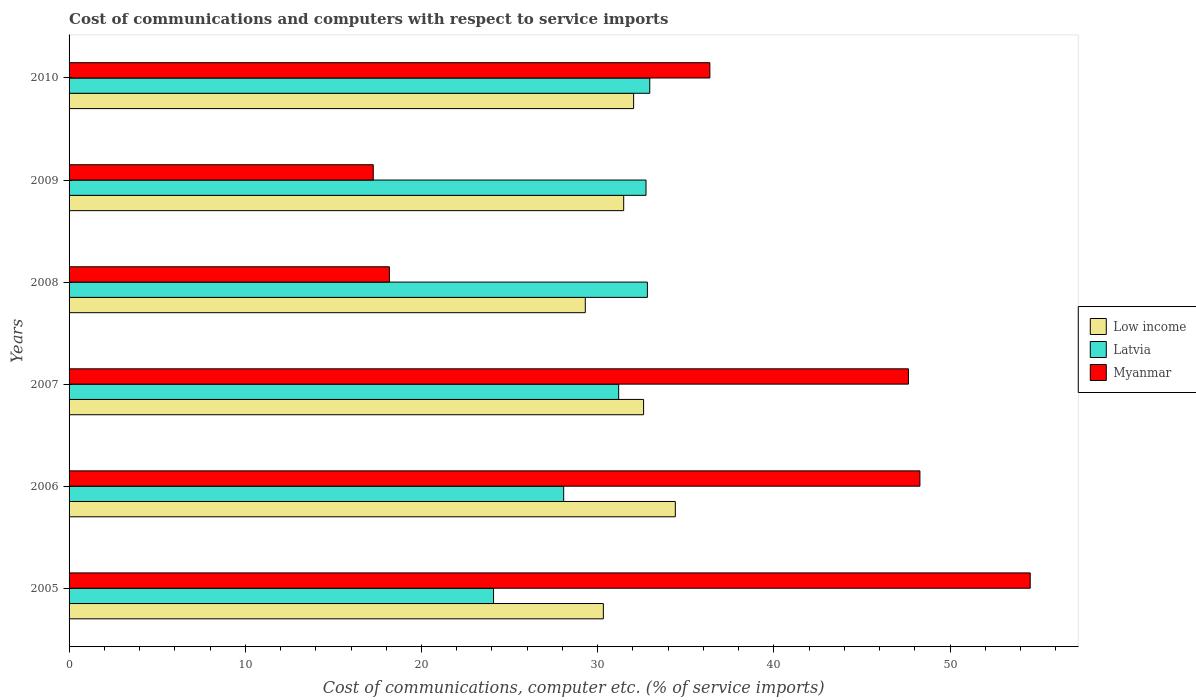How many different coloured bars are there?
Make the answer very short. 3. How many groups of bars are there?
Your response must be concise. 6. In how many cases, is the number of bars for a given year not equal to the number of legend labels?
Keep it short and to the point. 0. What is the cost of communications and computers in Latvia in 2006?
Make the answer very short. 28.07. Across all years, what is the maximum cost of communications and computers in Latvia?
Keep it short and to the point. 32.95. Across all years, what is the minimum cost of communications and computers in Myanmar?
Offer a terse response. 17.26. What is the total cost of communications and computers in Myanmar in the graph?
Provide a succinct answer. 222.28. What is the difference between the cost of communications and computers in Latvia in 2007 and that in 2008?
Make the answer very short. -1.63. What is the difference between the cost of communications and computers in Low income in 2010 and the cost of communications and computers in Latvia in 2008?
Provide a short and direct response. -0.78. What is the average cost of communications and computers in Latvia per year?
Keep it short and to the point. 30.31. In the year 2005, what is the difference between the cost of communications and computers in Myanmar and cost of communications and computers in Latvia?
Offer a very short reply. 30.46. In how many years, is the cost of communications and computers in Low income greater than 12 %?
Your response must be concise. 6. What is the ratio of the cost of communications and computers in Myanmar in 2005 to that in 2008?
Make the answer very short. 3. Is the difference between the cost of communications and computers in Myanmar in 2007 and 2009 greater than the difference between the cost of communications and computers in Latvia in 2007 and 2009?
Give a very brief answer. Yes. What is the difference between the highest and the second highest cost of communications and computers in Low income?
Your answer should be very brief. 1.8. What is the difference between the highest and the lowest cost of communications and computers in Latvia?
Your response must be concise. 8.87. In how many years, is the cost of communications and computers in Latvia greater than the average cost of communications and computers in Latvia taken over all years?
Offer a very short reply. 4. Is the sum of the cost of communications and computers in Low income in 2006 and 2008 greater than the maximum cost of communications and computers in Myanmar across all years?
Give a very brief answer. Yes. What does the 2nd bar from the top in 2009 represents?
Your answer should be very brief. Latvia. What does the 1st bar from the bottom in 2010 represents?
Offer a terse response. Low income. How many years are there in the graph?
Make the answer very short. 6. What is the difference between two consecutive major ticks on the X-axis?
Provide a short and direct response. 10. Are the values on the major ticks of X-axis written in scientific E-notation?
Give a very brief answer. No. How many legend labels are there?
Keep it short and to the point. 3. How are the legend labels stacked?
Your response must be concise. Vertical. What is the title of the graph?
Provide a succinct answer. Cost of communications and computers with respect to service imports. Does "OECD members" appear as one of the legend labels in the graph?
Offer a terse response. No. What is the label or title of the X-axis?
Provide a short and direct response. Cost of communications, computer etc. (% of service imports). What is the label or title of the Y-axis?
Provide a short and direct response. Years. What is the Cost of communications, computer etc. (% of service imports) in Low income in 2005?
Your answer should be compact. 30.32. What is the Cost of communications, computer etc. (% of service imports) in Latvia in 2005?
Ensure brevity in your answer.  24.09. What is the Cost of communications, computer etc. (% of service imports) in Myanmar in 2005?
Provide a succinct answer. 54.55. What is the Cost of communications, computer etc. (% of service imports) of Low income in 2006?
Your response must be concise. 34.41. What is the Cost of communications, computer etc. (% of service imports) of Latvia in 2006?
Ensure brevity in your answer.  28.07. What is the Cost of communications, computer etc. (% of service imports) in Myanmar in 2006?
Your response must be concise. 48.29. What is the Cost of communications, computer etc. (% of service imports) of Low income in 2007?
Offer a very short reply. 32.6. What is the Cost of communications, computer etc. (% of service imports) of Latvia in 2007?
Ensure brevity in your answer.  31.19. What is the Cost of communications, computer etc. (% of service imports) of Myanmar in 2007?
Provide a succinct answer. 47.64. What is the Cost of communications, computer etc. (% of service imports) in Low income in 2008?
Your response must be concise. 29.3. What is the Cost of communications, computer etc. (% of service imports) in Latvia in 2008?
Ensure brevity in your answer.  32.82. What is the Cost of communications, computer etc. (% of service imports) in Myanmar in 2008?
Provide a short and direct response. 18.18. What is the Cost of communications, computer etc. (% of service imports) of Low income in 2009?
Make the answer very short. 31.48. What is the Cost of communications, computer etc. (% of service imports) of Latvia in 2009?
Give a very brief answer. 32.74. What is the Cost of communications, computer etc. (% of service imports) of Myanmar in 2009?
Provide a succinct answer. 17.26. What is the Cost of communications, computer etc. (% of service imports) in Low income in 2010?
Offer a terse response. 32.04. What is the Cost of communications, computer etc. (% of service imports) of Latvia in 2010?
Your answer should be compact. 32.95. What is the Cost of communications, computer etc. (% of service imports) of Myanmar in 2010?
Ensure brevity in your answer.  36.37. Across all years, what is the maximum Cost of communications, computer etc. (% of service imports) of Low income?
Provide a short and direct response. 34.41. Across all years, what is the maximum Cost of communications, computer etc. (% of service imports) in Latvia?
Provide a short and direct response. 32.95. Across all years, what is the maximum Cost of communications, computer etc. (% of service imports) of Myanmar?
Ensure brevity in your answer.  54.55. Across all years, what is the minimum Cost of communications, computer etc. (% of service imports) of Low income?
Give a very brief answer. 29.3. Across all years, what is the minimum Cost of communications, computer etc. (% of service imports) of Latvia?
Provide a short and direct response. 24.09. Across all years, what is the minimum Cost of communications, computer etc. (% of service imports) in Myanmar?
Make the answer very short. 17.26. What is the total Cost of communications, computer etc. (% of service imports) of Low income in the graph?
Provide a short and direct response. 190.14. What is the total Cost of communications, computer etc. (% of service imports) of Latvia in the graph?
Ensure brevity in your answer.  181.87. What is the total Cost of communications, computer etc. (% of service imports) in Myanmar in the graph?
Make the answer very short. 222.28. What is the difference between the Cost of communications, computer etc. (% of service imports) of Low income in 2005 and that in 2006?
Provide a succinct answer. -4.08. What is the difference between the Cost of communications, computer etc. (% of service imports) of Latvia in 2005 and that in 2006?
Offer a very short reply. -3.98. What is the difference between the Cost of communications, computer etc. (% of service imports) of Myanmar in 2005 and that in 2006?
Ensure brevity in your answer.  6.26. What is the difference between the Cost of communications, computer etc. (% of service imports) in Low income in 2005 and that in 2007?
Your answer should be compact. -2.28. What is the difference between the Cost of communications, computer etc. (% of service imports) of Latvia in 2005 and that in 2007?
Your answer should be compact. -7.1. What is the difference between the Cost of communications, computer etc. (% of service imports) in Myanmar in 2005 and that in 2007?
Your answer should be very brief. 6.91. What is the difference between the Cost of communications, computer etc. (% of service imports) of Low income in 2005 and that in 2008?
Give a very brief answer. 1.03. What is the difference between the Cost of communications, computer etc. (% of service imports) of Latvia in 2005 and that in 2008?
Your answer should be very brief. -8.73. What is the difference between the Cost of communications, computer etc. (% of service imports) of Myanmar in 2005 and that in 2008?
Your response must be concise. 36.37. What is the difference between the Cost of communications, computer etc. (% of service imports) of Low income in 2005 and that in 2009?
Offer a terse response. -1.15. What is the difference between the Cost of communications, computer etc. (% of service imports) of Latvia in 2005 and that in 2009?
Your answer should be compact. -8.65. What is the difference between the Cost of communications, computer etc. (% of service imports) in Myanmar in 2005 and that in 2009?
Ensure brevity in your answer.  37.28. What is the difference between the Cost of communications, computer etc. (% of service imports) of Low income in 2005 and that in 2010?
Your answer should be compact. -1.72. What is the difference between the Cost of communications, computer etc. (% of service imports) of Latvia in 2005 and that in 2010?
Your answer should be very brief. -8.87. What is the difference between the Cost of communications, computer etc. (% of service imports) of Myanmar in 2005 and that in 2010?
Your answer should be very brief. 18.18. What is the difference between the Cost of communications, computer etc. (% of service imports) in Low income in 2006 and that in 2007?
Ensure brevity in your answer.  1.8. What is the difference between the Cost of communications, computer etc. (% of service imports) in Latvia in 2006 and that in 2007?
Keep it short and to the point. -3.12. What is the difference between the Cost of communications, computer etc. (% of service imports) of Myanmar in 2006 and that in 2007?
Make the answer very short. 0.65. What is the difference between the Cost of communications, computer etc. (% of service imports) in Low income in 2006 and that in 2008?
Your answer should be very brief. 5.11. What is the difference between the Cost of communications, computer etc. (% of service imports) of Latvia in 2006 and that in 2008?
Keep it short and to the point. -4.75. What is the difference between the Cost of communications, computer etc. (% of service imports) in Myanmar in 2006 and that in 2008?
Offer a very short reply. 30.11. What is the difference between the Cost of communications, computer etc. (% of service imports) in Low income in 2006 and that in 2009?
Offer a terse response. 2.93. What is the difference between the Cost of communications, computer etc. (% of service imports) in Latvia in 2006 and that in 2009?
Give a very brief answer. -4.67. What is the difference between the Cost of communications, computer etc. (% of service imports) of Myanmar in 2006 and that in 2009?
Offer a terse response. 31.02. What is the difference between the Cost of communications, computer etc. (% of service imports) in Low income in 2006 and that in 2010?
Ensure brevity in your answer.  2.37. What is the difference between the Cost of communications, computer etc. (% of service imports) of Latvia in 2006 and that in 2010?
Your answer should be compact. -4.88. What is the difference between the Cost of communications, computer etc. (% of service imports) in Myanmar in 2006 and that in 2010?
Your answer should be very brief. 11.92. What is the difference between the Cost of communications, computer etc. (% of service imports) of Low income in 2007 and that in 2008?
Ensure brevity in your answer.  3.31. What is the difference between the Cost of communications, computer etc. (% of service imports) of Latvia in 2007 and that in 2008?
Your response must be concise. -1.63. What is the difference between the Cost of communications, computer etc. (% of service imports) in Myanmar in 2007 and that in 2008?
Offer a terse response. 29.46. What is the difference between the Cost of communications, computer etc. (% of service imports) in Low income in 2007 and that in 2009?
Make the answer very short. 1.13. What is the difference between the Cost of communications, computer etc. (% of service imports) in Latvia in 2007 and that in 2009?
Offer a very short reply. -1.55. What is the difference between the Cost of communications, computer etc. (% of service imports) of Myanmar in 2007 and that in 2009?
Your answer should be very brief. 30.37. What is the difference between the Cost of communications, computer etc. (% of service imports) in Low income in 2007 and that in 2010?
Your response must be concise. 0.57. What is the difference between the Cost of communications, computer etc. (% of service imports) in Latvia in 2007 and that in 2010?
Offer a terse response. -1.76. What is the difference between the Cost of communications, computer etc. (% of service imports) of Myanmar in 2007 and that in 2010?
Make the answer very short. 11.27. What is the difference between the Cost of communications, computer etc. (% of service imports) of Low income in 2008 and that in 2009?
Provide a succinct answer. -2.18. What is the difference between the Cost of communications, computer etc. (% of service imports) in Latvia in 2008 and that in 2009?
Offer a terse response. 0.08. What is the difference between the Cost of communications, computer etc. (% of service imports) in Myanmar in 2008 and that in 2009?
Give a very brief answer. 0.92. What is the difference between the Cost of communications, computer etc. (% of service imports) of Low income in 2008 and that in 2010?
Provide a succinct answer. -2.74. What is the difference between the Cost of communications, computer etc. (% of service imports) of Latvia in 2008 and that in 2010?
Ensure brevity in your answer.  -0.13. What is the difference between the Cost of communications, computer etc. (% of service imports) of Myanmar in 2008 and that in 2010?
Your response must be concise. -18.19. What is the difference between the Cost of communications, computer etc. (% of service imports) of Low income in 2009 and that in 2010?
Your answer should be very brief. -0.56. What is the difference between the Cost of communications, computer etc. (% of service imports) of Latvia in 2009 and that in 2010?
Offer a very short reply. -0.21. What is the difference between the Cost of communications, computer etc. (% of service imports) in Myanmar in 2009 and that in 2010?
Provide a succinct answer. -19.1. What is the difference between the Cost of communications, computer etc. (% of service imports) in Low income in 2005 and the Cost of communications, computer etc. (% of service imports) in Latvia in 2006?
Your answer should be compact. 2.25. What is the difference between the Cost of communications, computer etc. (% of service imports) in Low income in 2005 and the Cost of communications, computer etc. (% of service imports) in Myanmar in 2006?
Offer a very short reply. -17.97. What is the difference between the Cost of communications, computer etc. (% of service imports) of Latvia in 2005 and the Cost of communications, computer etc. (% of service imports) of Myanmar in 2006?
Ensure brevity in your answer.  -24.2. What is the difference between the Cost of communications, computer etc. (% of service imports) of Low income in 2005 and the Cost of communications, computer etc. (% of service imports) of Latvia in 2007?
Give a very brief answer. -0.87. What is the difference between the Cost of communications, computer etc. (% of service imports) of Low income in 2005 and the Cost of communications, computer etc. (% of service imports) of Myanmar in 2007?
Provide a succinct answer. -17.31. What is the difference between the Cost of communications, computer etc. (% of service imports) of Latvia in 2005 and the Cost of communications, computer etc. (% of service imports) of Myanmar in 2007?
Make the answer very short. -23.55. What is the difference between the Cost of communications, computer etc. (% of service imports) of Low income in 2005 and the Cost of communications, computer etc. (% of service imports) of Latvia in 2008?
Provide a succinct answer. -2.5. What is the difference between the Cost of communications, computer etc. (% of service imports) in Low income in 2005 and the Cost of communications, computer etc. (% of service imports) in Myanmar in 2008?
Provide a short and direct response. 12.14. What is the difference between the Cost of communications, computer etc. (% of service imports) in Latvia in 2005 and the Cost of communications, computer etc. (% of service imports) in Myanmar in 2008?
Offer a very short reply. 5.91. What is the difference between the Cost of communications, computer etc. (% of service imports) in Low income in 2005 and the Cost of communications, computer etc. (% of service imports) in Latvia in 2009?
Ensure brevity in your answer.  -2.42. What is the difference between the Cost of communications, computer etc. (% of service imports) of Low income in 2005 and the Cost of communications, computer etc. (% of service imports) of Myanmar in 2009?
Offer a very short reply. 13.06. What is the difference between the Cost of communications, computer etc. (% of service imports) in Latvia in 2005 and the Cost of communications, computer etc. (% of service imports) in Myanmar in 2009?
Provide a succinct answer. 6.83. What is the difference between the Cost of communications, computer etc. (% of service imports) in Low income in 2005 and the Cost of communications, computer etc. (% of service imports) in Latvia in 2010?
Your response must be concise. -2.63. What is the difference between the Cost of communications, computer etc. (% of service imports) in Low income in 2005 and the Cost of communications, computer etc. (% of service imports) in Myanmar in 2010?
Provide a short and direct response. -6.04. What is the difference between the Cost of communications, computer etc. (% of service imports) in Latvia in 2005 and the Cost of communications, computer etc. (% of service imports) in Myanmar in 2010?
Offer a terse response. -12.28. What is the difference between the Cost of communications, computer etc. (% of service imports) in Low income in 2006 and the Cost of communications, computer etc. (% of service imports) in Latvia in 2007?
Make the answer very short. 3.21. What is the difference between the Cost of communications, computer etc. (% of service imports) in Low income in 2006 and the Cost of communications, computer etc. (% of service imports) in Myanmar in 2007?
Provide a short and direct response. -13.23. What is the difference between the Cost of communications, computer etc. (% of service imports) in Latvia in 2006 and the Cost of communications, computer etc. (% of service imports) in Myanmar in 2007?
Your response must be concise. -19.57. What is the difference between the Cost of communications, computer etc. (% of service imports) of Low income in 2006 and the Cost of communications, computer etc. (% of service imports) of Latvia in 2008?
Your response must be concise. 1.58. What is the difference between the Cost of communications, computer etc. (% of service imports) in Low income in 2006 and the Cost of communications, computer etc. (% of service imports) in Myanmar in 2008?
Offer a terse response. 16.23. What is the difference between the Cost of communications, computer etc. (% of service imports) of Latvia in 2006 and the Cost of communications, computer etc. (% of service imports) of Myanmar in 2008?
Provide a succinct answer. 9.89. What is the difference between the Cost of communications, computer etc. (% of service imports) in Low income in 2006 and the Cost of communications, computer etc. (% of service imports) in Latvia in 2009?
Make the answer very short. 1.66. What is the difference between the Cost of communications, computer etc. (% of service imports) in Low income in 2006 and the Cost of communications, computer etc. (% of service imports) in Myanmar in 2009?
Provide a short and direct response. 17.14. What is the difference between the Cost of communications, computer etc. (% of service imports) in Latvia in 2006 and the Cost of communications, computer etc. (% of service imports) in Myanmar in 2009?
Ensure brevity in your answer.  10.81. What is the difference between the Cost of communications, computer etc. (% of service imports) of Low income in 2006 and the Cost of communications, computer etc. (% of service imports) of Latvia in 2010?
Your answer should be very brief. 1.45. What is the difference between the Cost of communications, computer etc. (% of service imports) in Low income in 2006 and the Cost of communications, computer etc. (% of service imports) in Myanmar in 2010?
Give a very brief answer. -1.96. What is the difference between the Cost of communications, computer etc. (% of service imports) in Latvia in 2006 and the Cost of communications, computer etc. (% of service imports) in Myanmar in 2010?
Your answer should be compact. -8.3. What is the difference between the Cost of communications, computer etc. (% of service imports) in Low income in 2007 and the Cost of communications, computer etc. (% of service imports) in Latvia in 2008?
Keep it short and to the point. -0.22. What is the difference between the Cost of communications, computer etc. (% of service imports) in Low income in 2007 and the Cost of communications, computer etc. (% of service imports) in Myanmar in 2008?
Your answer should be very brief. 14.43. What is the difference between the Cost of communications, computer etc. (% of service imports) in Latvia in 2007 and the Cost of communications, computer etc. (% of service imports) in Myanmar in 2008?
Your answer should be compact. 13.01. What is the difference between the Cost of communications, computer etc. (% of service imports) of Low income in 2007 and the Cost of communications, computer etc. (% of service imports) of Latvia in 2009?
Offer a terse response. -0.14. What is the difference between the Cost of communications, computer etc. (% of service imports) in Low income in 2007 and the Cost of communications, computer etc. (% of service imports) in Myanmar in 2009?
Provide a succinct answer. 15.34. What is the difference between the Cost of communications, computer etc. (% of service imports) in Latvia in 2007 and the Cost of communications, computer etc. (% of service imports) in Myanmar in 2009?
Your answer should be compact. 13.93. What is the difference between the Cost of communications, computer etc. (% of service imports) of Low income in 2007 and the Cost of communications, computer etc. (% of service imports) of Latvia in 2010?
Provide a succinct answer. -0.35. What is the difference between the Cost of communications, computer etc. (% of service imports) of Low income in 2007 and the Cost of communications, computer etc. (% of service imports) of Myanmar in 2010?
Make the answer very short. -3.76. What is the difference between the Cost of communications, computer etc. (% of service imports) of Latvia in 2007 and the Cost of communications, computer etc. (% of service imports) of Myanmar in 2010?
Your response must be concise. -5.17. What is the difference between the Cost of communications, computer etc. (% of service imports) of Low income in 2008 and the Cost of communications, computer etc. (% of service imports) of Latvia in 2009?
Offer a terse response. -3.45. What is the difference between the Cost of communications, computer etc. (% of service imports) of Low income in 2008 and the Cost of communications, computer etc. (% of service imports) of Myanmar in 2009?
Provide a short and direct response. 12.03. What is the difference between the Cost of communications, computer etc. (% of service imports) of Latvia in 2008 and the Cost of communications, computer etc. (% of service imports) of Myanmar in 2009?
Ensure brevity in your answer.  15.56. What is the difference between the Cost of communications, computer etc. (% of service imports) of Low income in 2008 and the Cost of communications, computer etc. (% of service imports) of Latvia in 2010?
Ensure brevity in your answer.  -3.66. What is the difference between the Cost of communications, computer etc. (% of service imports) of Low income in 2008 and the Cost of communications, computer etc. (% of service imports) of Myanmar in 2010?
Your response must be concise. -7.07. What is the difference between the Cost of communications, computer etc. (% of service imports) of Latvia in 2008 and the Cost of communications, computer etc. (% of service imports) of Myanmar in 2010?
Keep it short and to the point. -3.54. What is the difference between the Cost of communications, computer etc. (% of service imports) of Low income in 2009 and the Cost of communications, computer etc. (% of service imports) of Latvia in 2010?
Make the answer very short. -1.48. What is the difference between the Cost of communications, computer etc. (% of service imports) of Low income in 2009 and the Cost of communications, computer etc. (% of service imports) of Myanmar in 2010?
Your response must be concise. -4.89. What is the difference between the Cost of communications, computer etc. (% of service imports) in Latvia in 2009 and the Cost of communications, computer etc. (% of service imports) in Myanmar in 2010?
Offer a terse response. -3.62. What is the average Cost of communications, computer etc. (% of service imports) of Low income per year?
Provide a short and direct response. 31.69. What is the average Cost of communications, computer etc. (% of service imports) of Latvia per year?
Your answer should be very brief. 30.31. What is the average Cost of communications, computer etc. (% of service imports) in Myanmar per year?
Provide a short and direct response. 37.05. In the year 2005, what is the difference between the Cost of communications, computer etc. (% of service imports) in Low income and Cost of communications, computer etc. (% of service imports) in Latvia?
Offer a very short reply. 6.23. In the year 2005, what is the difference between the Cost of communications, computer etc. (% of service imports) of Low income and Cost of communications, computer etc. (% of service imports) of Myanmar?
Give a very brief answer. -24.22. In the year 2005, what is the difference between the Cost of communications, computer etc. (% of service imports) of Latvia and Cost of communications, computer etc. (% of service imports) of Myanmar?
Keep it short and to the point. -30.46. In the year 2006, what is the difference between the Cost of communications, computer etc. (% of service imports) in Low income and Cost of communications, computer etc. (% of service imports) in Latvia?
Your answer should be very brief. 6.34. In the year 2006, what is the difference between the Cost of communications, computer etc. (% of service imports) of Low income and Cost of communications, computer etc. (% of service imports) of Myanmar?
Your answer should be compact. -13.88. In the year 2006, what is the difference between the Cost of communications, computer etc. (% of service imports) of Latvia and Cost of communications, computer etc. (% of service imports) of Myanmar?
Ensure brevity in your answer.  -20.22. In the year 2007, what is the difference between the Cost of communications, computer etc. (% of service imports) in Low income and Cost of communications, computer etc. (% of service imports) in Latvia?
Provide a short and direct response. 1.41. In the year 2007, what is the difference between the Cost of communications, computer etc. (% of service imports) in Low income and Cost of communications, computer etc. (% of service imports) in Myanmar?
Your answer should be very brief. -15.03. In the year 2007, what is the difference between the Cost of communications, computer etc. (% of service imports) of Latvia and Cost of communications, computer etc. (% of service imports) of Myanmar?
Provide a short and direct response. -16.44. In the year 2008, what is the difference between the Cost of communications, computer etc. (% of service imports) of Low income and Cost of communications, computer etc. (% of service imports) of Latvia?
Provide a succinct answer. -3.52. In the year 2008, what is the difference between the Cost of communications, computer etc. (% of service imports) in Low income and Cost of communications, computer etc. (% of service imports) in Myanmar?
Ensure brevity in your answer.  11.12. In the year 2008, what is the difference between the Cost of communications, computer etc. (% of service imports) of Latvia and Cost of communications, computer etc. (% of service imports) of Myanmar?
Ensure brevity in your answer.  14.64. In the year 2009, what is the difference between the Cost of communications, computer etc. (% of service imports) of Low income and Cost of communications, computer etc. (% of service imports) of Latvia?
Ensure brevity in your answer.  -1.27. In the year 2009, what is the difference between the Cost of communications, computer etc. (% of service imports) in Low income and Cost of communications, computer etc. (% of service imports) in Myanmar?
Make the answer very short. 14.21. In the year 2009, what is the difference between the Cost of communications, computer etc. (% of service imports) of Latvia and Cost of communications, computer etc. (% of service imports) of Myanmar?
Your answer should be compact. 15.48. In the year 2010, what is the difference between the Cost of communications, computer etc. (% of service imports) of Low income and Cost of communications, computer etc. (% of service imports) of Latvia?
Provide a short and direct response. -0.92. In the year 2010, what is the difference between the Cost of communications, computer etc. (% of service imports) in Low income and Cost of communications, computer etc. (% of service imports) in Myanmar?
Offer a very short reply. -4.33. In the year 2010, what is the difference between the Cost of communications, computer etc. (% of service imports) of Latvia and Cost of communications, computer etc. (% of service imports) of Myanmar?
Offer a very short reply. -3.41. What is the ratio of the Cost of communications, computer etc. (% of service imports) of Low income in 2005 to that in 2006?
Provide a succinct answer. 0.88. What is the ratio of the Cost of communications, computer etc. (% of service imports) of Latvia in 2005 to that in 2006?
Make the answer very short. 0.86. What is the ratio of the Cost of communications, computer etc. (% of service imports) of Myanmar in 2005 to that in 2006?
Give a very brief answer. 1.13. What is the ratio of the Cost of communications, computer etc. (% of service imports) of Latvia in 2005 to that in 2007?
Your response must be concise. 0.77. What is the ratio of the Cost of communications, computer etc. (% of service imports) of Myanmar in 2005 to that in 2007?
Keep it short and to the point. 1.15. What is the ratio of the Cost of communications, computer etc. (% of service imports) of Low income in 2005 to that in 2008?
Keep it short and to the point. 1.03. What is the ratio of the Cost of communications, computer etc. (% of service imports) in Latvia in 2005 to that in 2008?
Offer a very short reply. 0.73. What is the ratio of the Cost of communications, computer etc. (% of service imports) of Myanmar in 2005 to that in 2008?
Provide a succinct answer. 3. What is the ratio of the Cost of communications, computer etc. (% of service imports) in Low income in 2005 to that in 2009?
Your response must be concise. 0.96. What is the ratio of the Cost of communications, computer etc. (% of service imports) of Latvia in 2005 to that in 2009?
Your answer should be very brief. 0.74. What is the ratio of the Cost of communications, computer etc. (% of service imports) of Myanmar in 2005 to that in 2009?
Provide a short and direct response. 3.16. What is the ratio of the Cost of communications, computer etc. (% of service imports) of Low income in 2005 to that in 2010?
Your answer should be compact. 0.95. What is the ratio of the Cost of communications, computer etc. (% of service imports) of Latvia in 2005 to that in 2010?
Ensure brevity in your answer.  0.73. What is the ratio of the Cost of communications, computer etc. (% of service imports) in Myanmar in 2005 to that in 2010?
Offer a terse response. 1.5. What is the ratio of the Cost of communications, computer etc. (% of service imports) in Low income in 2006 to that in 2007?
Provide a short and direct response. 1.06. What is the ratio of the Cost of communications, computer etc. (% of service imports) of Latvia in 2006 to that in 2007?
Provide a short and direct response. 0.9. What is the ratio of the Cost of communications, computer etc. (% of service imports) of Myanmar in 2006 to that in 2007?
Your answer should be very brief. 1.01. What is the ratio of the Cost of communications, computer etc. (% of service imports) in Low income in 2006 to that in 2008?
Provide a short and direct response. 1.17. What is the ratio of the Cost of communications, computer etc. (% of service imports) in Latvia in 2006 to that in 2008?
Ensure brevity in your answer.  0.86. What is the ratio of the Cost of communications, computer etc. (% of service imports) in Myanmar in 2006 to that in 2008?
Give a very brief answer. 2.66. What is the ratio of the Cost of communications, computer etc. (% of service imports) of Low income in 2006 to that in 2009?
Your answer should be compact. 1.09. What is the ratio of the Cost of communications, computer etc. (% of service imports) of Latvia in 2006 to that in 2009?
Your response must be concise. 0.86. What is the ratio of the Cost of communications, computer etc. (% of service imports) in Myanmar in 2006 to that in 2009?
Offer a very short reply. 2.8. What is the ratio of the Cost of communications, computer etc. (% of service imports) of Low income in 2006 to that in 2010?
Provide a succinct answer. 1.07. What is the ratio of the Cost of communications, computer etc. (% of service imports) of Latvia in 2006 to that in 2010?
Ensure brevity in your answer.  0.85. What is the ratio of the Cost of communications, computer etc. (% of service imports) of Myanmar in 2006 to that in 2010?
Keep it short and to the point. 1.33. What is the ratio of the Cost of communications, computer etc. (% of service imports) in Low income in 2007 to that in 2008?
Your answer should be very brief. 1.11. What is the ratio of the Cost of communications, computer etc. (% of service imports) of Latvia in 2007 to that in 2008?
Make the answer very short. 0.95. What is the ratio of the Cost of communications, computer etc. (% of service imports) in Myanmar in 2007 to that in 2008?
Provide a short and direct response. 2.62. What is the ratio of the Cost of communications, computer etc. (% of service imports) of Low income in 2007 to that in 2009?
Provide a short and direct response. 1.04. What is the ratio of the Cost of communications, computer etc. (% of service imports) of Latvia in 2007 to that in 2009?
Offer a very short reply. 0.95. What is the ratio of the Cost of communications, computer etc. (% of service imports) of Myanmar in 2007 to that in 2009?
Ensure brevity in your answer.  2.76. What is the ratio of the Cost of communications, computer etc. (% of service imports) of Low income in 2007 to that in 2010?
Your response must be concise. 1.02. What is the ratio of the Cost of communications, computer etc. (% of service imports) in Latvia in 2007 to that in 2010?
Your answer should be very brief. 0.95. What is the ratio of the Cost of communications, computer etc. (% of service imports) of Myanmar in 2007 to that in 2010?
Give a very brief answer. 1.31. What is the ratio of the Cost of communications, computer etc. (% of service imports) of Low income in 2008 to that in 2009?
Provide a short and direct response. 0.93. What is the ratio of the Cost of communications, computer etc. (% of service imports) of Myanmar in 2008 to that in 2009?
Provide a short and direct response. 1.05. What is the ratio of the Cost of communications, computer etc. (% of service imports) in Low income in 2008 to that in 2010?
Give a very brief answer. 0.91. What is the ratio of the Cost of communications, computer etc. (% of service imports) of Latvia in 2008 to that in 2010?
Give a very brief answer. 1. What is the ratio of the Cost of communications, computer etc. (% of service imports) of Myanmar in 2008 to that in 2010?
Ensure brevity in your answer.  0.5. What is the ratio of the Cost of communications, computer etc. (% of service imports) in Low income in 2009 to that in 2010?
Ensure brevity in your answer.  0.98. What is the ratio of the Cost of communications, computer etc. (% of service imports) of Latvia in 2009 to that in 2010?
Provide a succinct answer. 0.99. What is the ratio of the Cost of communications, computer etc. (% of service imports) of Myanmar in 2009 to that in 2010?
Your answer should be very brief. 0.47. What is the difference between the highest and the second highest Cost of communications, computer etc. (% of service imports) of Low income?
Provide a short and direct response. 1.8. What is the difference between the highest and the second highest Cost of communications, computer etc. (% of service imports) of Latvia?
Make the answer very short. 0.13. What is the difference between the highest and the second highest Cost of communications, computer etc. (% of service imports) in Myanmar?
Your response must be concise. 6.26. What is the difference between the highest and the lowest Cost of communications, computer etc. (% of service imports) of Low income?
Make the answer very short. 5.11. What is the difference between the highest and the lowest Cost of communications, computer etc. (% of service imports) of Latvia?
Give a very brief answer. 8.87. What is the difference between the highest and the lowest Cost of communications, computer etc. (% of service imports) of Myanmar?
Offer a very short reply. 37.28. 